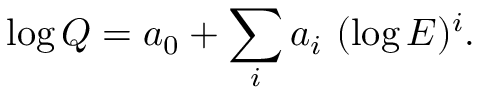Convert formula to latex. <formula><loc_0><loc_0><loc_500><loc_500>\log Q = a _ { 0 } + \sum _ { i } a _ { i } ( \log E ) ^ { i } .</formula> 